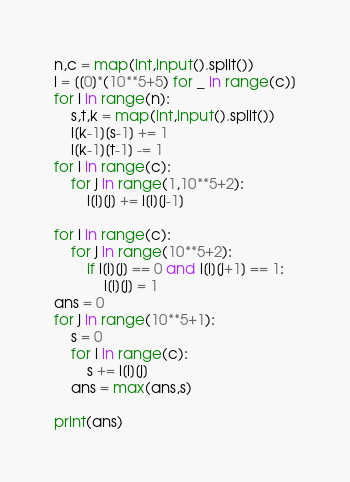<code> <loc_0><loc_0><loc_500><loc_500><_Python_>n,c = map(int,input().split())
l = [[0]*(10**5+5) for _ in range(c)]
for i in range(n):
    s,t,k = map(int,input().split())
    l[k-1][s-1] += 1
    l[k-1][t-1] -= 1
for i in range(c):
    for j in range(1,10**5+2):
        l[i][j] += l[i][j-1]

for i in range(c):
    for j in range(10**5+2):
        if l[i][j] == 0 and l[i][j+1] == 1:
            l[i][j] = 1
ans = 0
for j in range(10**5+1):
    s = 0
    for i in range(c):
        s += l[i][j]
    ans = max(ans,s)

print(ans)</code> 